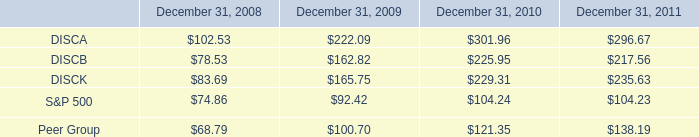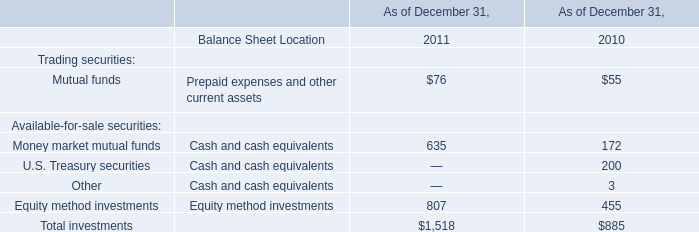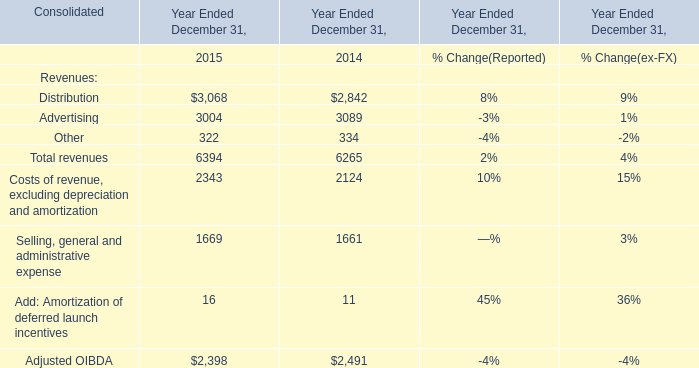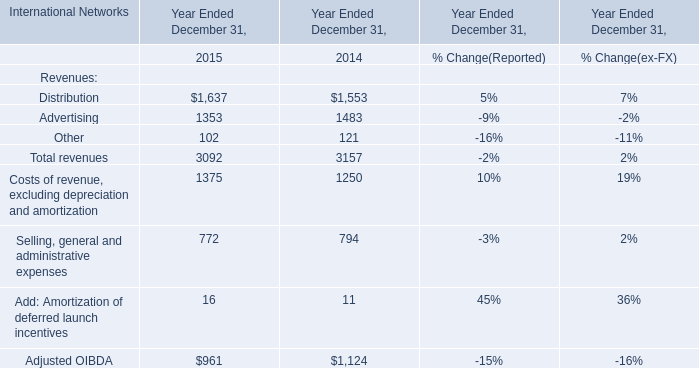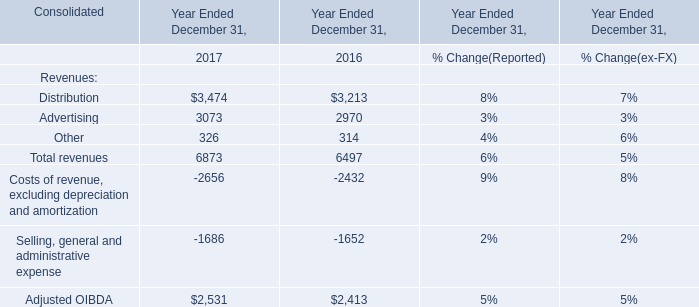What's the average of Distribution of Year Ended December 31, 2015, and Advertising of Year Ended December 31, 2014 ? 
Computations: ((1637.0 + 3089.0) / 2)
Answer: 2363.0. 